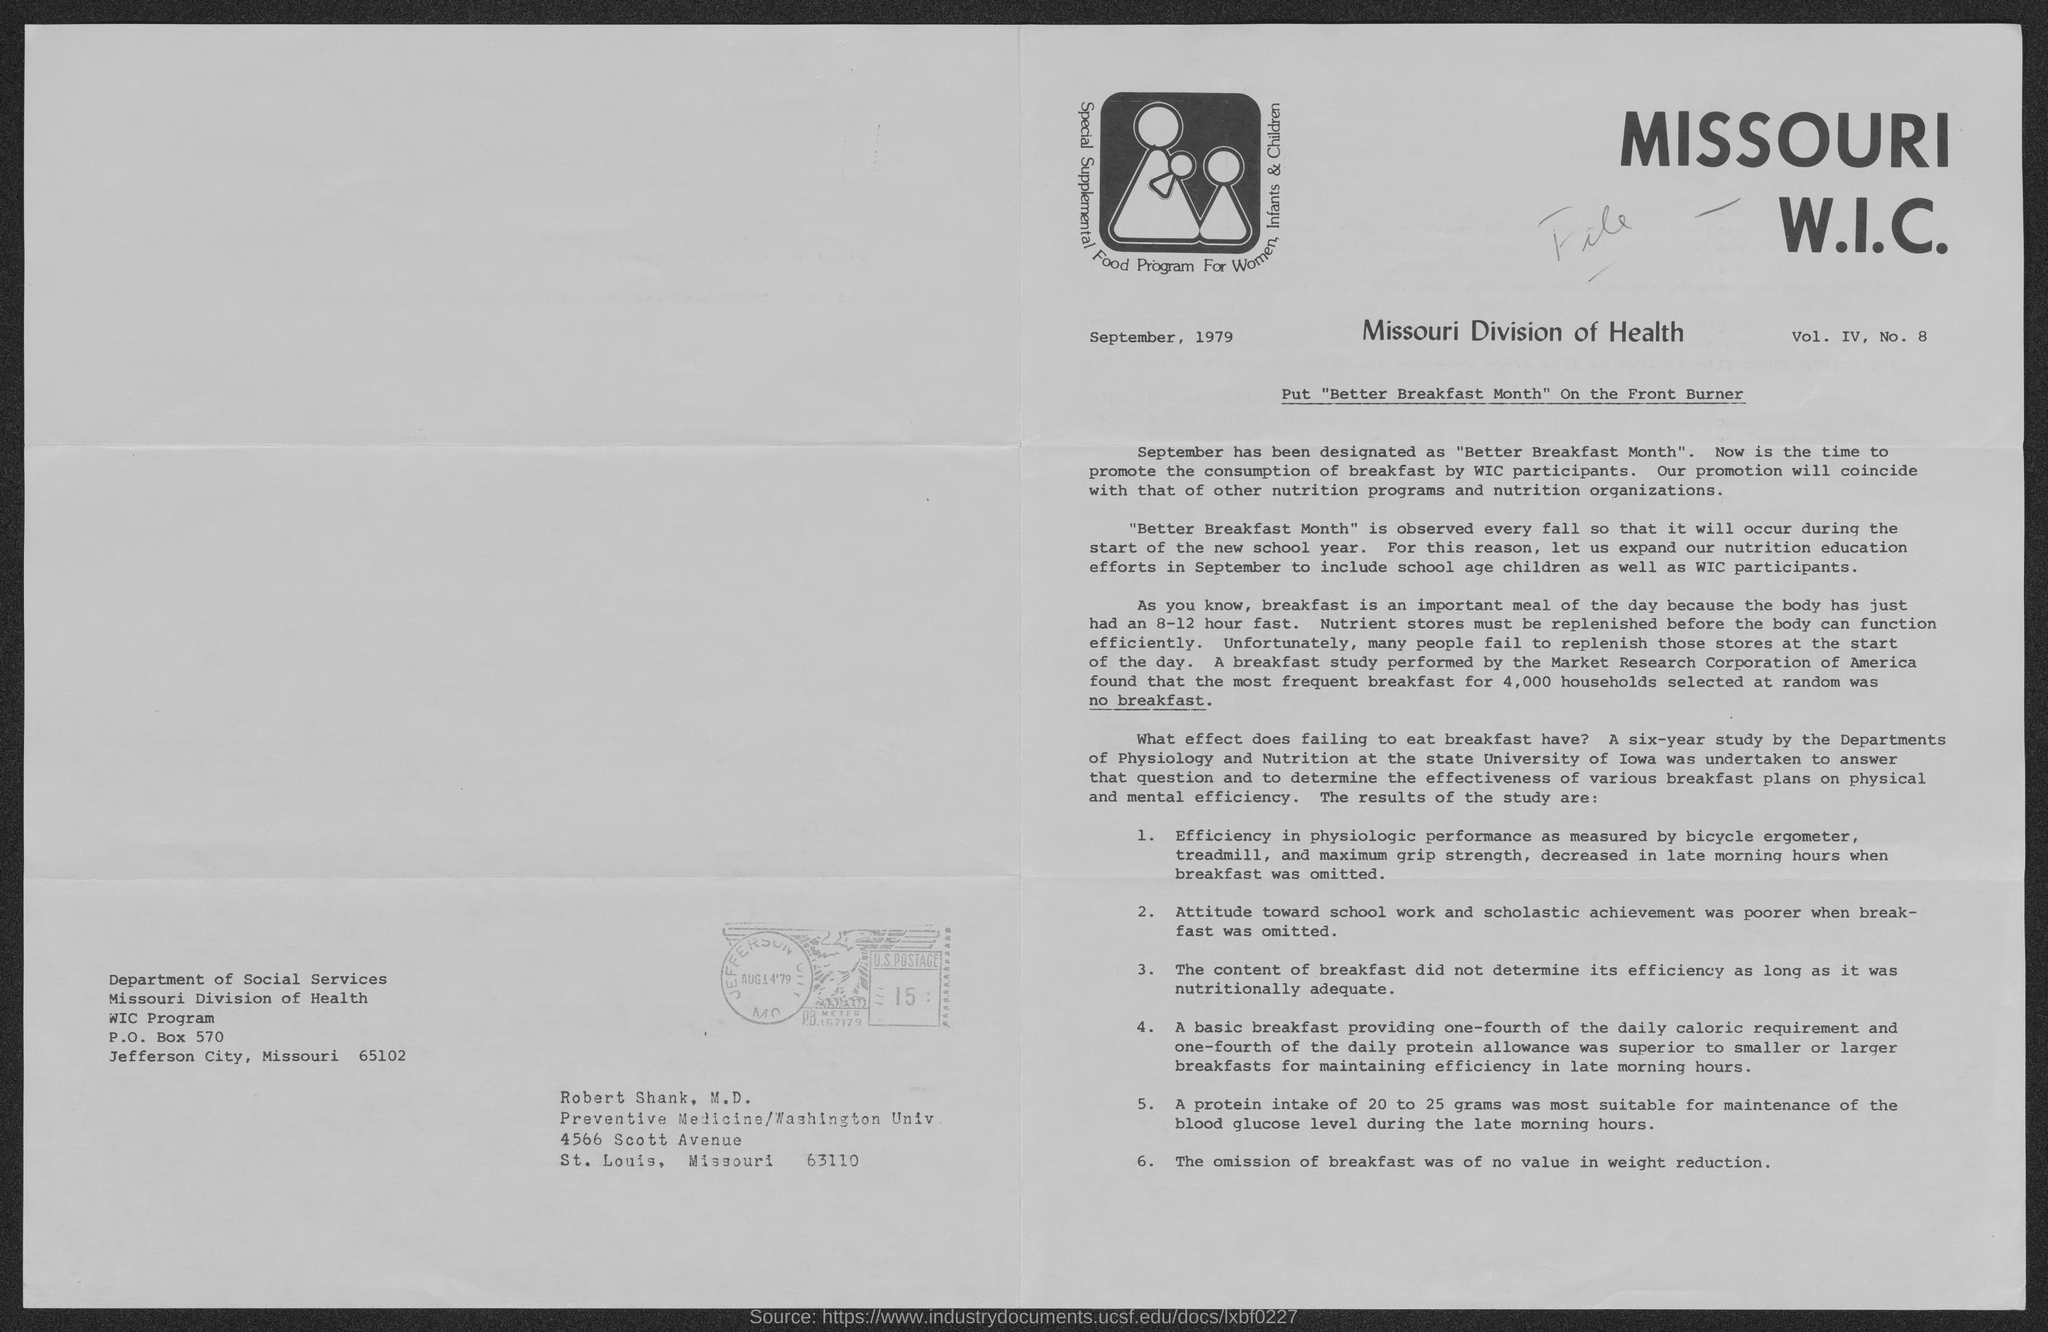What is the zipcode of missouri division of health ?
Your answer should be very brief. 65102. What is the p.o. box no. of missouri division of health ?
Offer a terse response. 570. In which state is missouri division of health located ?
Give a very brief answer. Missouri. In which  state is preventive medicine / washington univ. located ?
Make the answer very short. Missouri. 